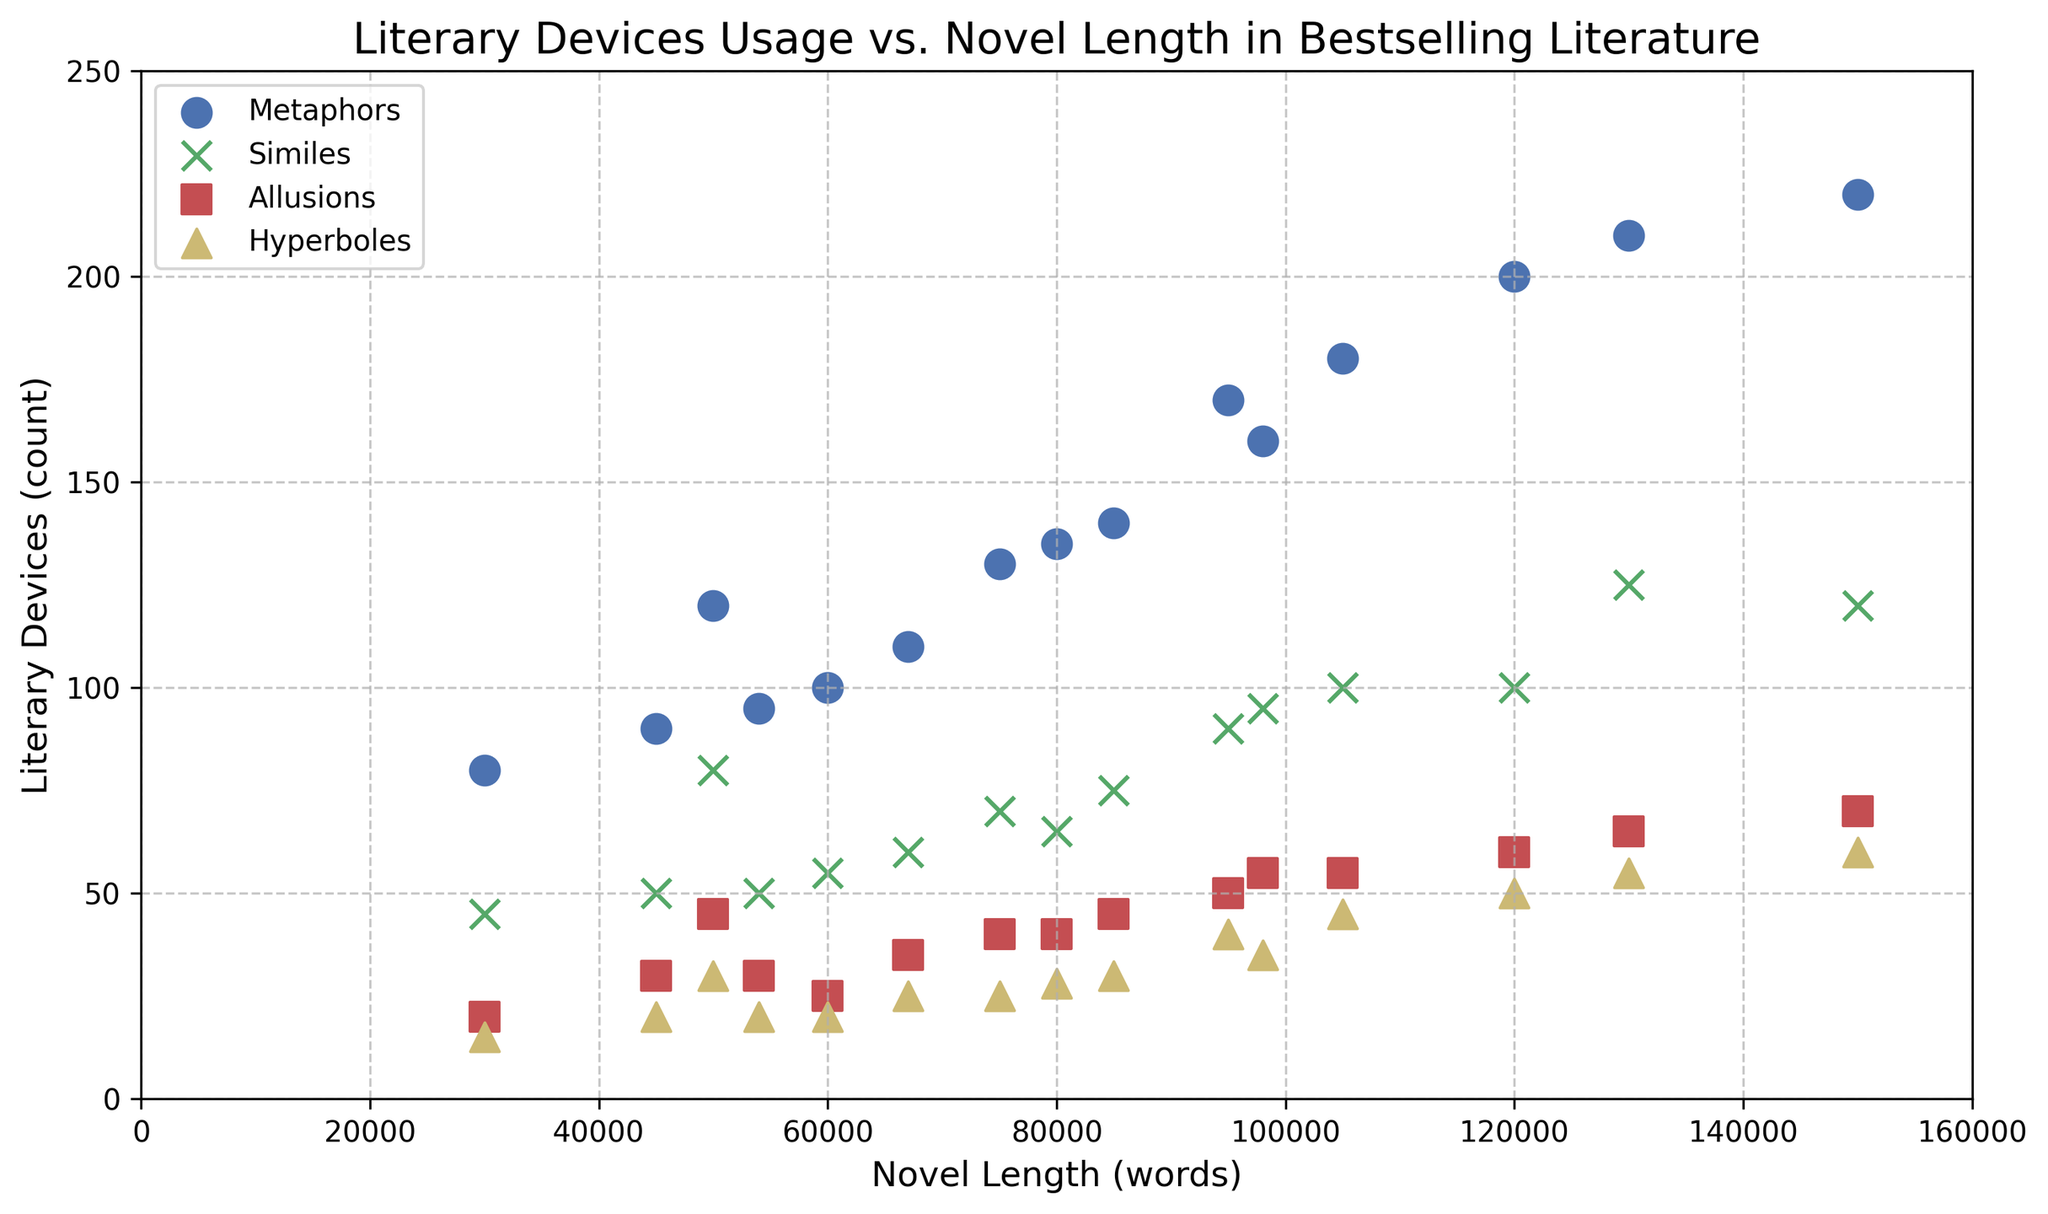What's the relationship between novel length and metaphors usage? By looking at the scatter plot, the blue dots representing metaphors show a positive trend, meaning as the novel length increases, the count of metaphors also increases.
Answer: Positive correlation Which literary device has the highest count in the longest novel? The longest novel is 150,000 words long. Among the markers for different devices at this point, the blue dot (metaphors) is at the highest position on the y-axis.
Answer: Metaphors What is the range of the count of hyperboles used? The yellow triangles representing hyperboles range from approximately 15 to 60 on the y-axis.
Answer: 15 to 60 For novels that are around 100,000 words, which literary device tends to be used the most? Around the 100,000-word mark on the x-axis, the blue dots (metaphors) are the highest, indicating metaphors are used the most.
Answer: Metaphors Compare the usage of similes in 75,000-word novels versus 85,000-word novels. The green 'x' markers show 70 counts for 75,000-word novels and 75 counts for 85,000-word novels, indicating the latter has slightly more similes.
Answer: 75,000-word: 70, 85,000-word: 75 Which literary device shows the least variation in usage across different novel lengths? The spread of data points for each device indicates the variation. The red squares representing allusions have the least vertical spread, showing the least variation.
Answer: Allusions Calculate the average number of metaphors in novels between 50,000 and 100,000 words. The relevant metaphors counts are 120, 130, 160, 90, 110, 170, and 140. Summing these up, 120+130+160+90+110+170+140=920, and the average is 920/7 ≈ 131.4.
Answer: 131.4 Which literary device has the most counts in the shortest novel? The shortest novel is 30,000 words. The markers for different devices at this point are blue (metaphors), green (similes), red (allusions), and yellow (hyperboles). The blue dot is the highest.
Answer: Metaphors Is there any novel length where all four literary devices have almost the same count? At 45,000 words, the red, green, yellow, and blue markers are relatively close to each other around 20-30 counts but not exactly the same. None are exactly the same, but 45,000 is the closest.
Answer: No exact match, closest at 45,000 How many novels use more than 200 metaphors? The scatter plot shows blue dots representing metaphors. Only novels at 120,000, 130,000, and 150,000 words have counts exceeding 200 indicating three such novels.
Answer: 3 novels 